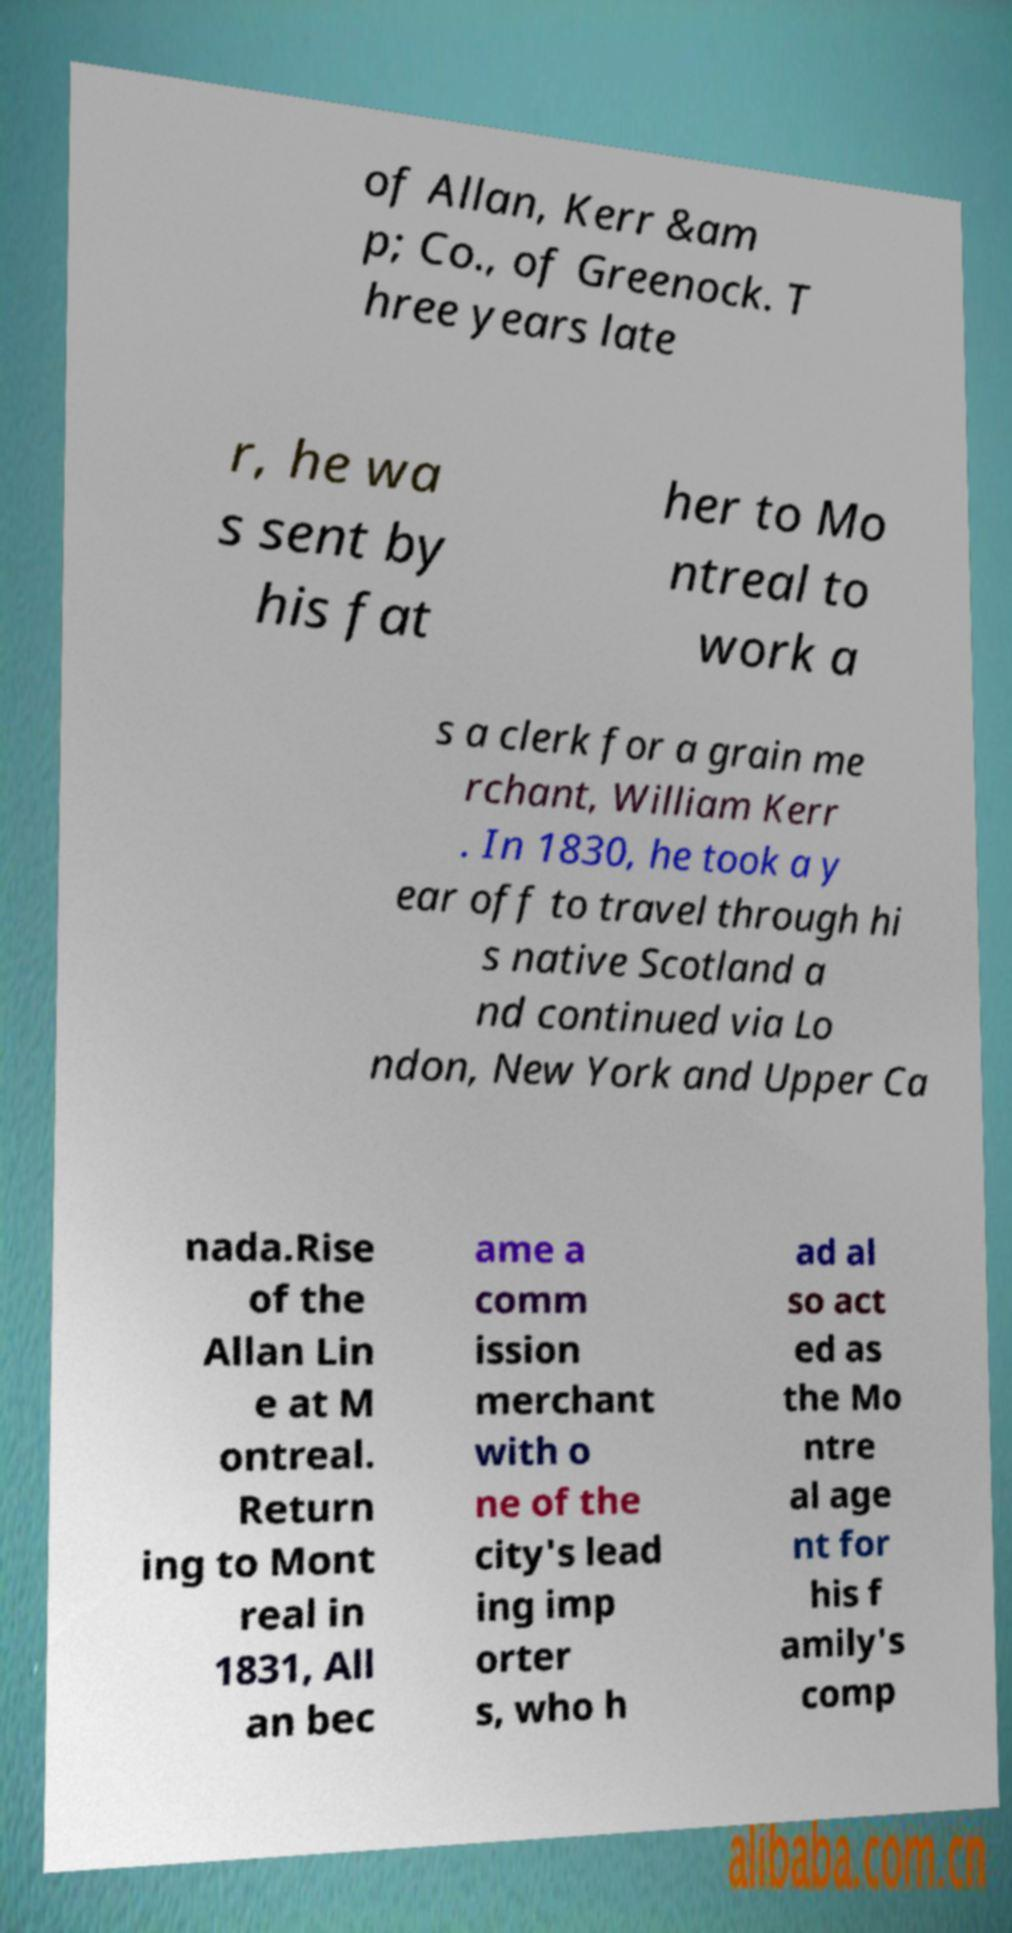What messages or text are displayed in this image? I need them in a readable, typed format. of Allan, Kerr &am p; Co., of Greenock. T hree years late r, he wa s sent by his fat her to Mo ntreal to work a s a clerk for a grain me rchant, William Kerr . In 1830, he took a y ear off to travel through hi s native Scotland a nd continued via Lo ndon, New York and Upper Ca nada.Rise of the Allan Lin e at M ontreal. Return ing to Mont real in 1831, All an bec ame a comm ission merchant with o ne of the city's lead ing imp orter s, who h ad al so act ed as the Mo ntre al age nt for his f amily's comp 